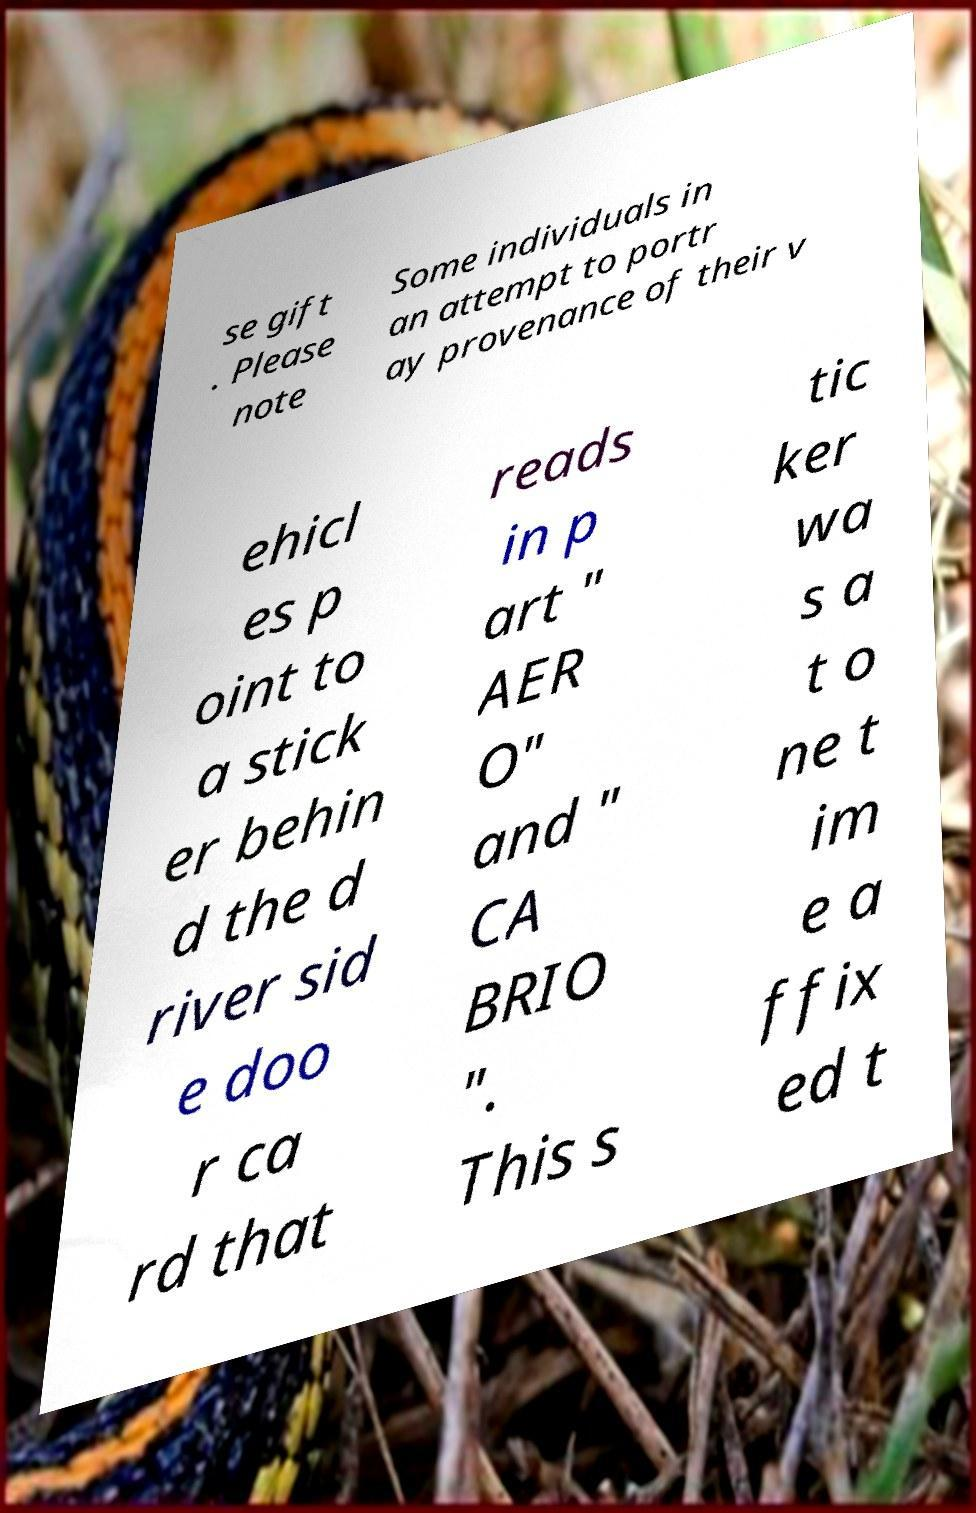Could you assist in decoding the text presented in this image and type it out clearly? se gift . Please note Some individuals in an attempt to portr ay provenance of their v ehicl es p oint to a stick er behin d the d river sid e doo r ca rd that reads in p art " AER O" and " CA BRIO ". This s tic ker wa s a t o ne t im e a ffix ed t 